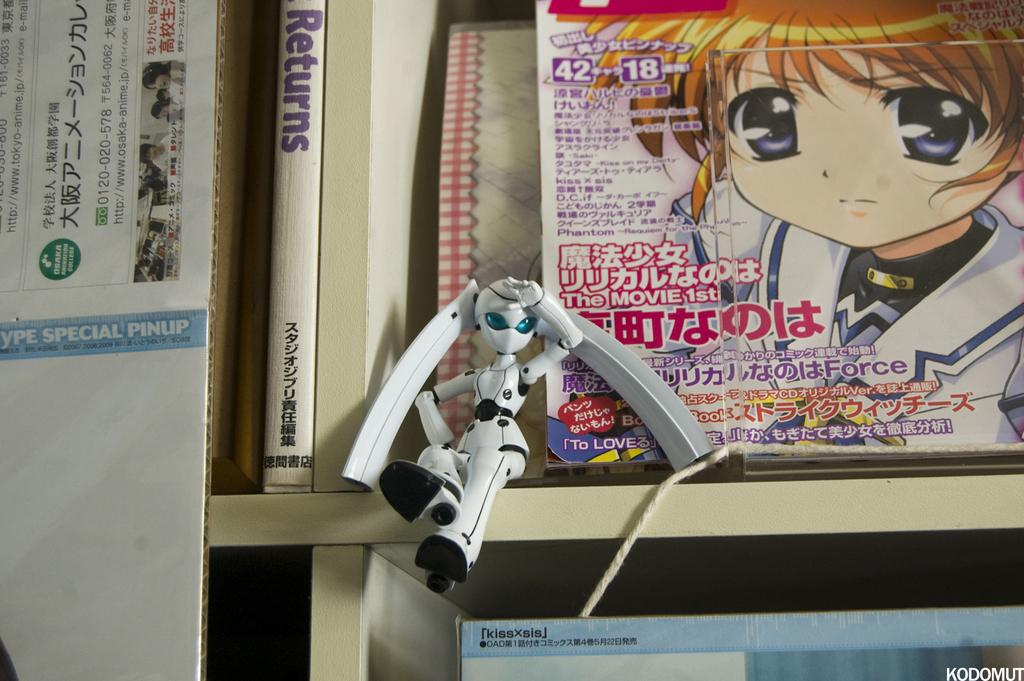Provide a one-sentence caption for the provided image. A doll sits on a shelf in front of an anime magazine with Japanese text on it next to the doll is a book with the title RETURNS. 